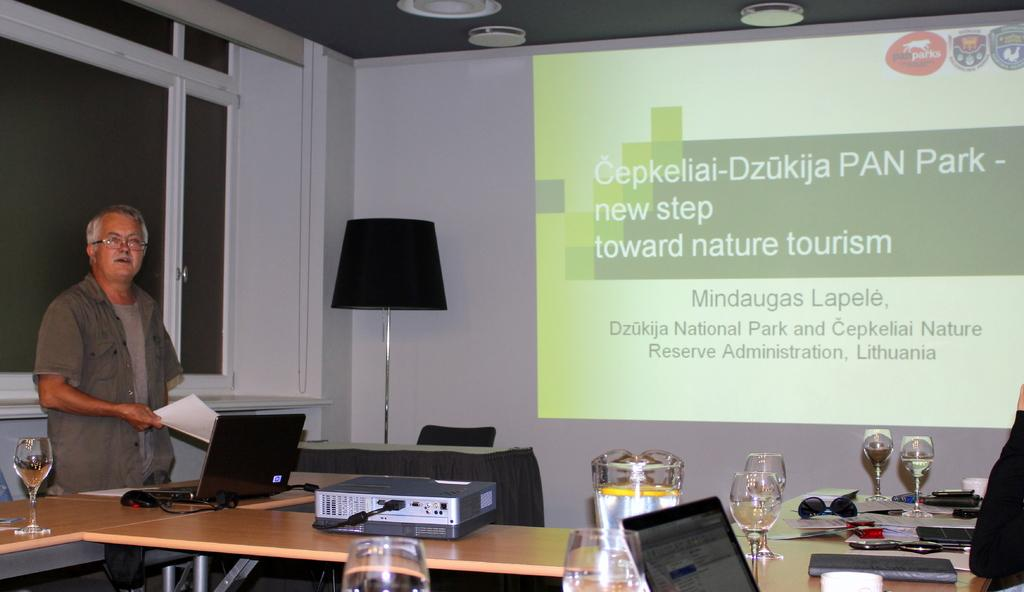<image>
Give a short and clear explanation of the subsequent image. A display discusses a Lithuanian national park and nature reserve. 